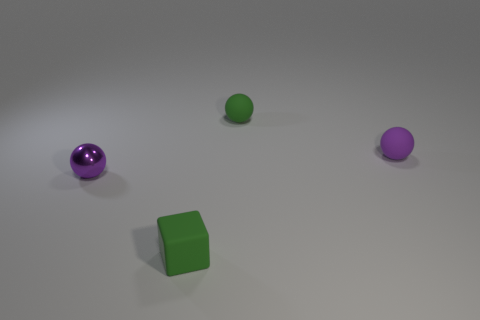Add 2 small matte objects. How many objects exist? 6 Subtract all cubes. How many objects are left? 3 Subtract 0 gray blocks. How many objects are left? 4 Subtract all matte balls. Subtract all big brown cubes. How many objects are left? 2 Add 2 purple matte spheres. How many purple matte spheres are left? 3 Add 4 large green matte blocks. How many large green matte blocks exist? 4 